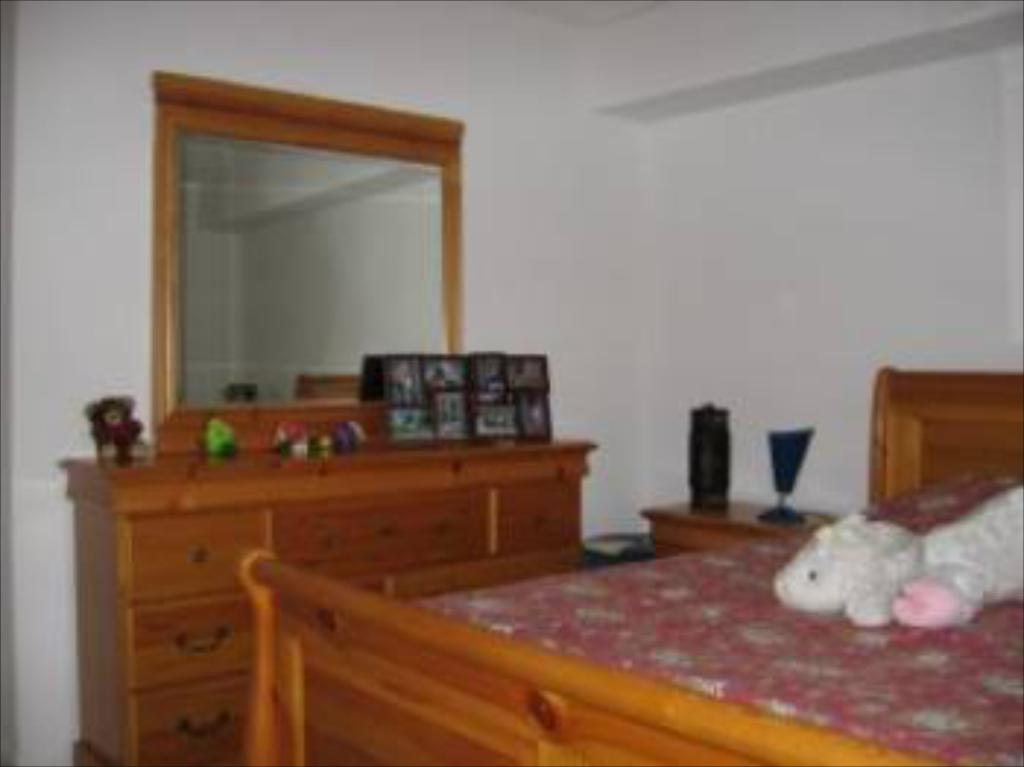What piece of furniture is present in the image? There is a bed in the image. What is placed on the bed? There is a toy on the bed. What reflective object is visible in the image? There is a mirror in the image. What type of storage furniture is present in the image? There are draws in the image. How many quarters are visible on the bed in the image? There are no quarters visible on the bed in the image. What route does the servant take to enter the room in the image? There is no servant or route present in the image. 